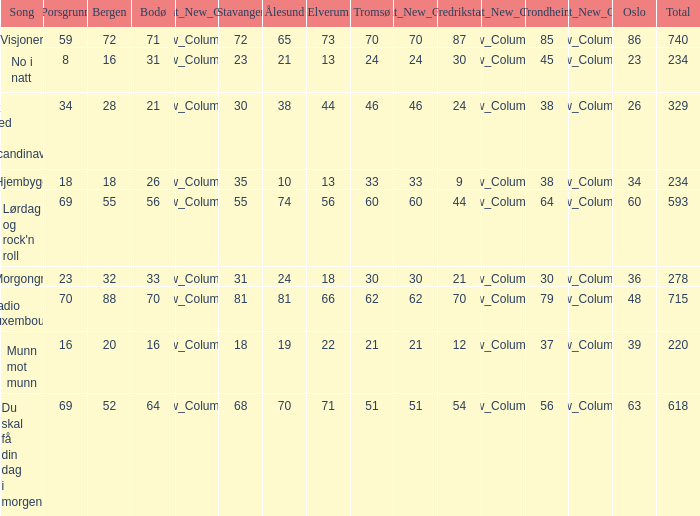When the cumulative score amounts to 740, what is tromso? 70.0. 